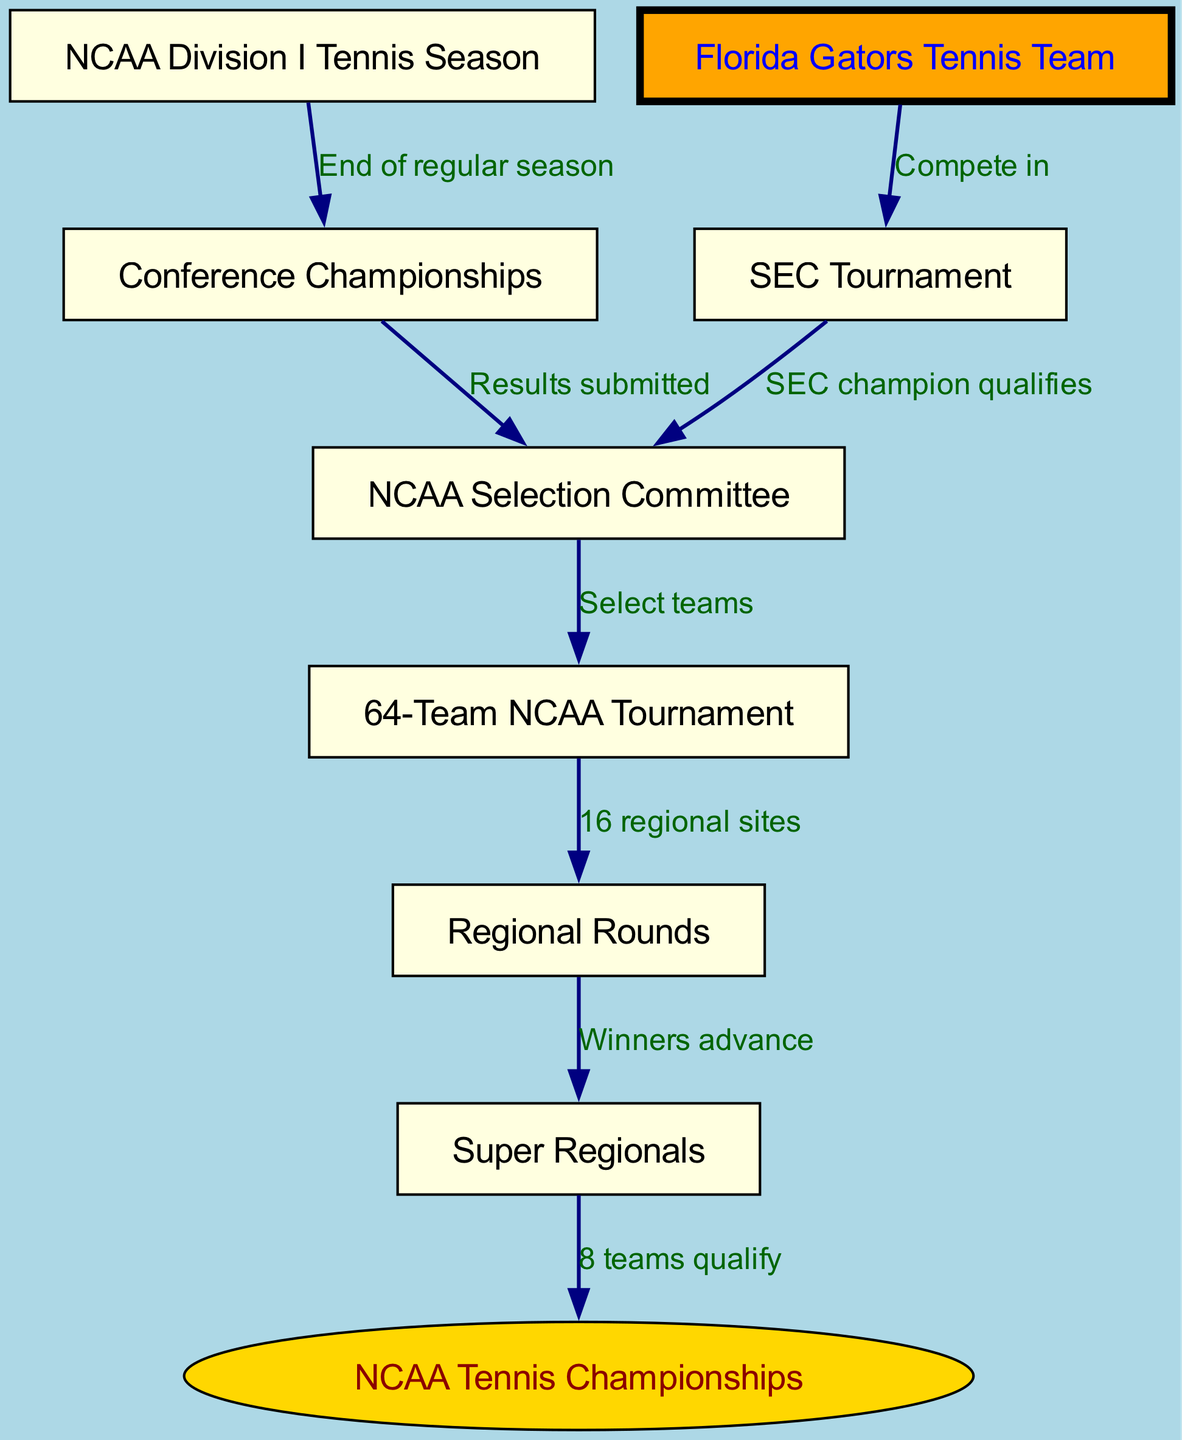What starts the NCAA Division I Tennis Tournament process? The NCAA Division I Tennis Tournament process starts at the end of the regular season, which is represented by the arrow from the "NCAA Division I Tennis Season" node to the "Conference Championships" node.
Answer: End of regular season Which team competes in the SEC Tournament? The diagram clearly indicates that the "Florida Gators Tennis Team" competes in the "SEC Tournament." This is evidenced by the arrow that connects these two nodes.
Answer: Florida Gators Tennis Team How many teams qualify for the NCAA Tennis Championships? The flowchart shows that 8 teams qualify for the NCAA Tennis Championships as indicated by the arrow going from "Super Regionals" to "NCAA Tennis Championships."
Answer: 8 teams What happens to the SEC champion after winning? According to the diagram, the SEC champion qualifies to be considered by the NCAA Selection Committee as indicated by the connection between the "SEC Tournament" and the "NCAA Selection Committee" nodes.
Answer: Qualifies What role does the NCAA Selection Committee play? The NCAA Selection Committee's role is to select teams for the NCAA tournament, demonstrated by the edge from "NCAA Selection Committee" to "64-Team NCAA Tournament." This signifies that it actively decides which teams are chosen.
Answer: Select teams What is the relationship between Regional Rounds and Super Regionals? The relationship shows that winners of the "Regional Rounds" advance to the "Super Regionals," which is reflected in the arrow connecting these two nodes.
Answer: Winners advance How many regional sites are there in the NCAA tournament? The diagram indicates that there are 16 regional sites in the NCAA tournament as shown by the arrow from "64-Team NCAA Tournament" to "Regional Rounds."
Answer: 16 regional sites What is highlighted differently in the diagram? The "Florida Gators Tennis Team" is highlighted differently in the diagram by using orange color, while other teams have a yellow background. This distinction emphasizes the focus on this particular team.
Answer: Florida Gators Tennis Team What key event concludes the NCAA Division I Tennis Tournament? The conclusion of the tournament is marked by the "NCAA Tennis Championships," as shown in the last node connected to the "Super Regionals." This indicates the final event after all rounds.
Answer: NCAA Tennis Championships 